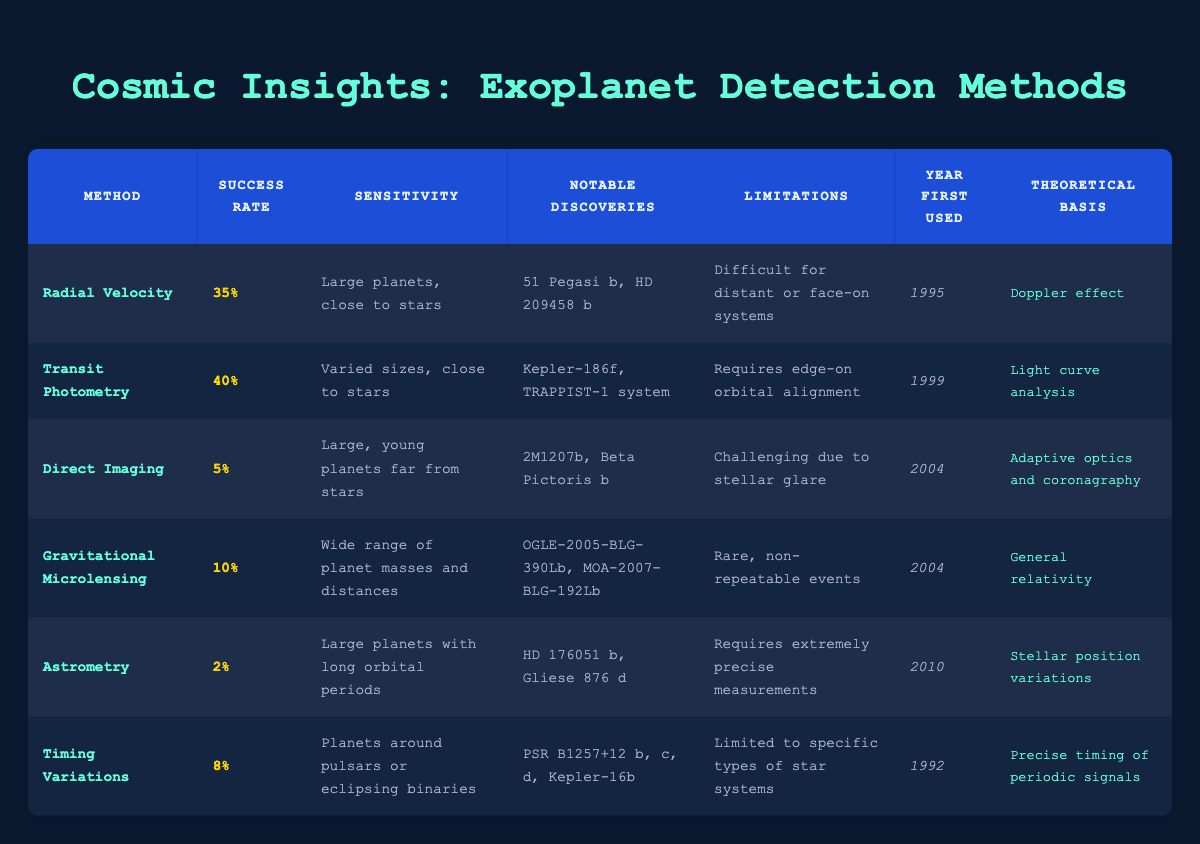What is the success rate of the Transit Photometry method? The success rate for the Transit Photometry method is listed directly in the table. It states "40%" under the Success Rate column for this method.
Answer: 40% Which exoplanet detection method has the highest success rate? Comparing the success rates in the table, Transit Photometry has the highest rate at 40%, which is more than Radial Velocity (35%) and all other methods.
Answer: Transit Photometry Is the Direct Imaging method suitable for detecting small planets near their stars? The sensitivity for Direct Imaging indicates it detects "Large, young planets far from stars," which means it is not suitable for small planets near their stars.
Answer: No How many notable discoveries are listed for the Gravitational Microlensing method? In the Gravitational Microlensing row, there are two notable discoveries listed: "OGLE-2005-BLG-390Lb" and "MOA-2007-BLG-192Lb," confirming that there are two entries in the Notable Discoveries column for this method.
Answer: 2 What is the average success rate for all the detection methods? To calculate the average success rate, we convert the percentages to decimals: (0.35 + 0.40 + 0.05 + 0.10 + 0.02 + 0.08) = 1.00. Dividing by the number of methods (6) gives an average rate of 1.00 / 6 = approximately 0.1667 or 16.67%.
Answer: 16.67% How many methods have a success rate of less than 10%? The methods with success rates below 10% are Direct Imaging (5%), Gravitational Microlensing (10%), Astrometry (2%), and Timing Variations (8%). This results in three methods below 10%.
Answer: 3 Does any detection method have a success rate above 35%? Checking the success rates, both Transit Photometry and Radial Velocity have rates above 35%, being 40% and 35%, respectively.
Answer: Yes Which method was first used in 1995 and what was its success rate? The Radial Velocity method was first used in 1995, and its corresponding success rate is "35%", listed in the table next to the method name.
Answer: 35% (Radial Velocity) 